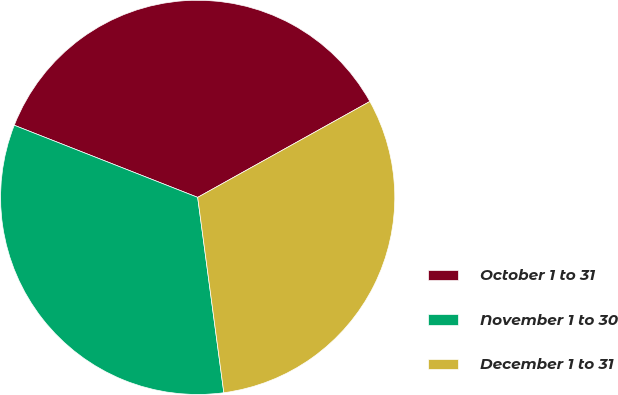Convert chart. <chart><loc_0><loc_0><loc_500><loc_500><pie_chart><fcel>October 1 to 31<fcel>November 1 to 30<fcel>December 1 to 31<nl><fcel>35.95%<fcel>33.08%<fcel>30.97%<nl></chart> 